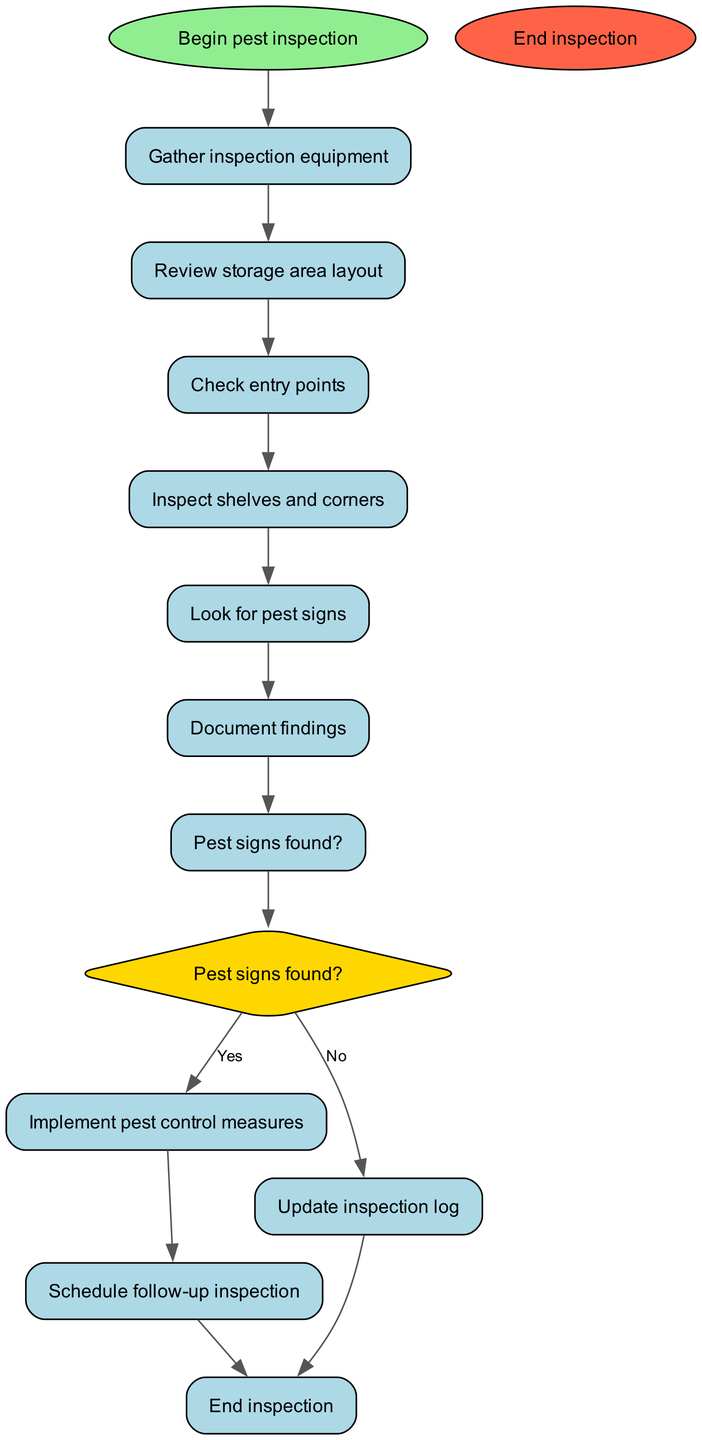What is the first step in the pest inspection process? The diagram starts with the node labeled "Begin pest inspection," indicating that this is the initial step.
Answer: Gather inspection equipment How many nodes are there in the diagram? By counting all distinct steps and decision points in the flowchart, there are 11 nodes in total.
Answer: 11 What is the decision point in the inspection process? The decision point occurs at node "7," where it asks "Pest signs found?" This determines whether to implement pest control measures or update the inspection log.
Answer: Pest signs found? What action follows after finding pest signs? If pest signs are found, the next action as indicated is "Implement pest control measures" at node "8." This means specific actions are taken to control the detected pests.
Answer: Implement pest control measures What is the last step of the inspection process? The final step as shown in the diagram is labeled "End inspection," indicating the conclusion of the pest inspection process.
Answer: End inspection If no pest signs are found, what is the next step? If no pest signs are found (the "No" path from the decision point), the next step is to "Update inspection log" at node "10."
Answer: Update inspection log Which task comes immediately after "Check entry points"? The immediate next task after "Check entry points" at node "3" is "Inspect shelves and corners" at node "4." This sequential flow indicates the order of actions in the inspection.
Answer: Inspect shelves and corners What comes after the documentation of findings? After documenting the findings at node "6," the next step is to assess whether pest signs were found, which leads to the decision point at node "7."
Answer: Pest signs found? 